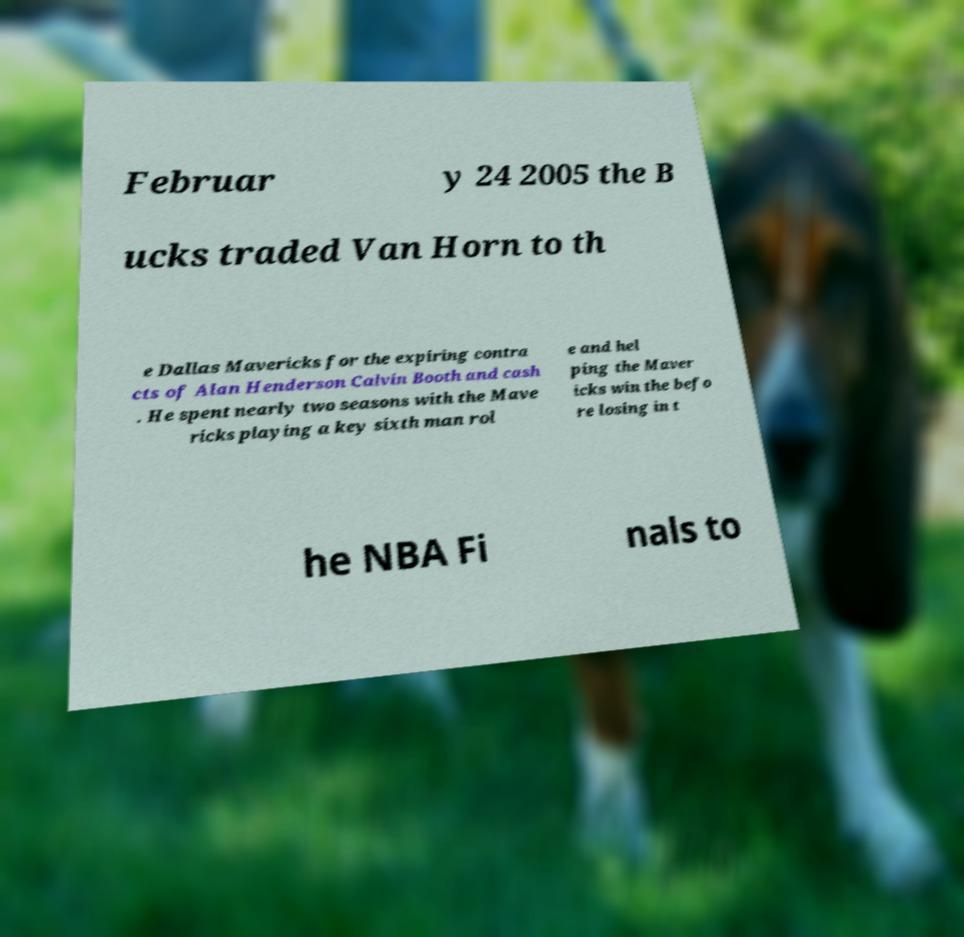For documentation purposes, I need the text within this image transcribed. Could you provide that? Februar y 24 2005 the B ucks traded Van Horn to th e Dallas Mavericks for the expiring contra cts of Alan Henderson Calvin Booth and cash . He spent nearly two seasons with the Mave ricks playing a key sixth man rol e and hel ping the Maver icks win the befo re losing in t he NBA Fi nals to 